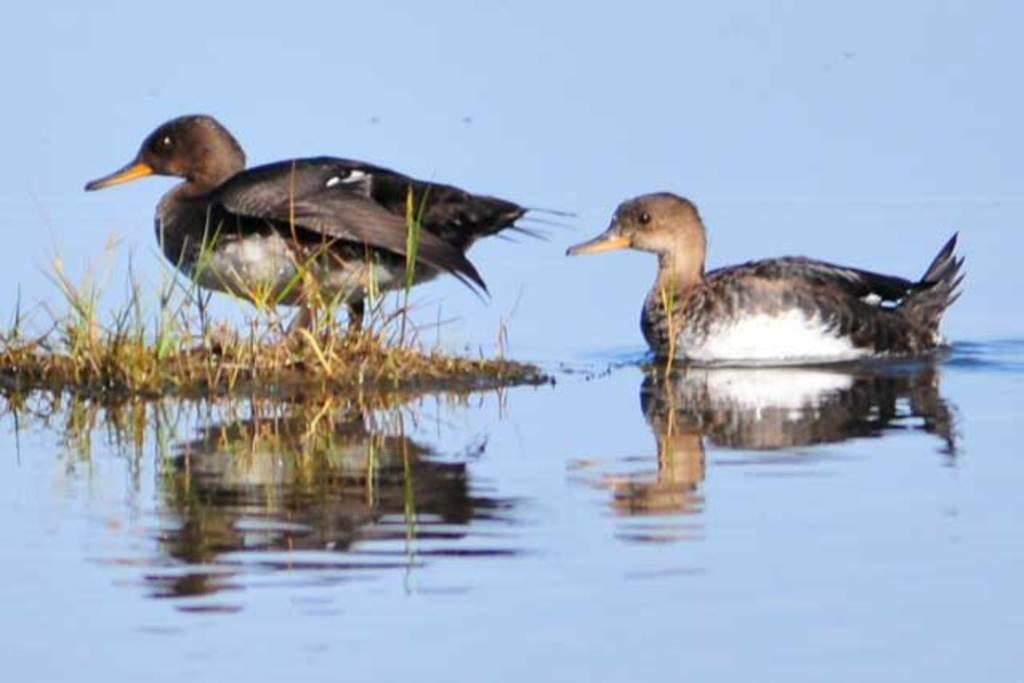Please provide a concise description of this image. In this image we can see ducks in the water and on the grass. At the bottom of the image there are some water. We can see some reflections in the water. At the top of the image there is water. 